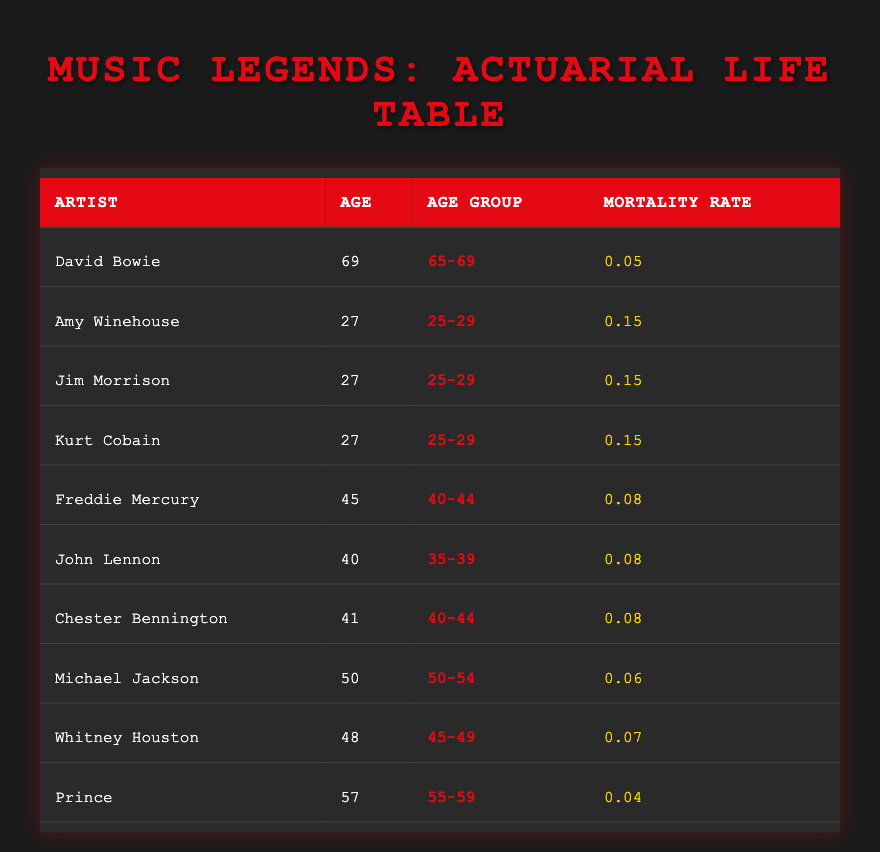What's the mortality rate for David Bowie? The table shows David Bowie's mortality rate listed under the "Mortality Rate" column. According to the data, David Bowie's mortality rate is 0.05.
Answer: 0.05 How many artists are in the age group 25-29? The table lists three artists: Amy Winehouse, Jim Morrison, and Kurt Cobain, all of whom belong to the age group 25-29. Therefore, there are 3 artists in this age group.
Answer: 3 Which age group has the lowest mortality rate? To answer this, I scan the "Mortality Rate" column for the lowest value. The mortality rates are 0.05, 0.06, 0.07, 0.08, and 0.15. The lowest rate is 0.04, which corresponds to the age group 55-59 (Prince).
Answer: 55-59 What is the average mortality rate of artists in the age group 40-44? The artists in this age group are Freddie Mercury, Chester Bennington, and the mortality rates are both 0.08. To find the average, sum the rates (0.08 + 0.08) and divide by the number of artists (2): 0.08 / 2 = 0.08.
Answer: 0.08 Is it true that Michael Jackson's age group has a higher mortality rate than Whitney Houston's age group? Michael Jackson is in the age group 50-54 with a mortality rate of 0.06, while Whitney Houston is in the age group 45-49 with a mortality rate of 0.07. Since 0.06 is less than 0.07, the statement is false.
Answer: No What is the total number of artists listed in the table? Counting each row in the table, there are ten artists listed (David Bowie, Amy Winehouse, Jim Morrison, Kurt Cobain, Freddie Mercury, John Lennon, Chester Bennington, Michael Jackson, Whitney Houston, and Prince), making the total 10.
Answer: 10 Which artist has the highest mortality rate? Looking through the "Mortality Rate" column, the highest rate is 0.15, found in the age group 25-29. The artists listed in that group are Amy Winehouse, Jim Morrison, and Kurt Cobain. Therefore, any of them can be considered to have the highest mortality rate at 0.15.
Answer: Amy Winehouse, Jim Morrison, or Kurt Cobain What is the difference in mortality rate between the ages 40-44 and 50-54? The mortality rate for the age group 40-44 (Freddie Mercury and Chester Bennington) is 0.08. The rate for age group 50-54 (Michael Jackson) is 0.06. The difference is 0.08 - 0.06 = 0.02.
Answer: 0.02 